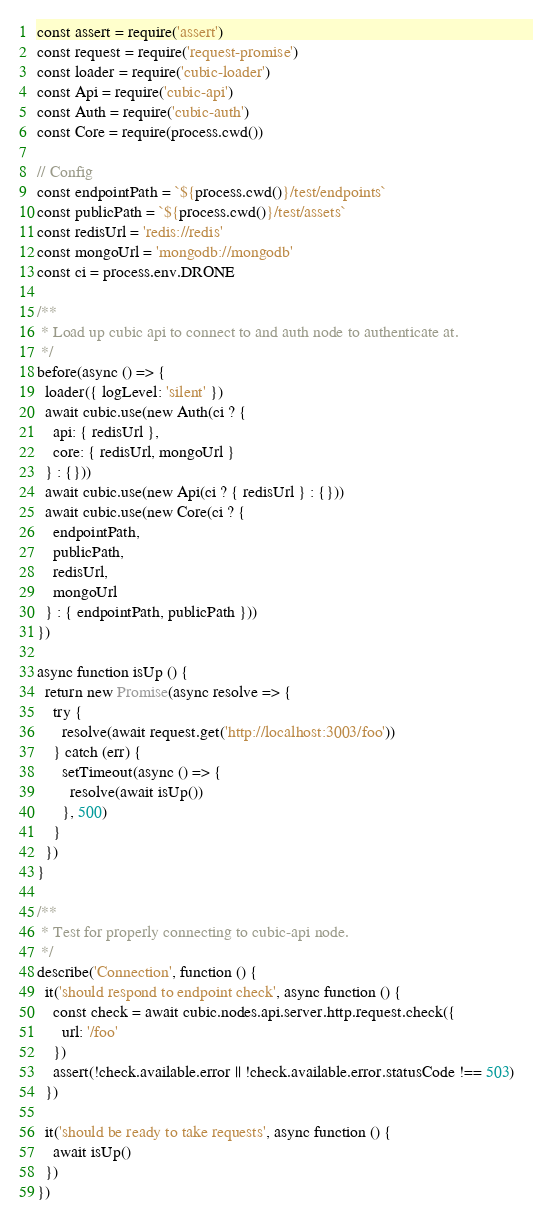Convert code to text. <code><loc_0><loc_0><loc_500><loc_500><_JavaScript_>const assert = require('assert')
const request = require('request-promise')
const loader = require('cubic-loader')
const Api = require('cubic-api')
const Auth = require('cubic-auth')
const Core = require(process.cwd())

// Config
const endpointPath = `${process.cwd()}/test/endpoints`
const publicPath = `${process.cwd()}/test/assets`
const redisUrl = 'redis://redis'
const mongoUrl = 'mongodb://mongodb'
const ci = process.env.DRONE

/**
 * Load up cubic api to connect to and auth node to authenticate at.
 */
before(async () => {
  loader({ logLevel: 'silent' })
  await cubic.use(new Auth(ci ? {
    api: { redisUrl },
    core: { redisUrl, mongoUrl }
  } : {}))
  await cubic.use(new Api(ci ? { redisUrl } : {}))
  await cubic.use(new Core(ci ? {
    endpointPath,
    publicPath,
    redisUrl,
    mongoUrl
  } : { endpointPath, publicPath }))
})

async function isUp () {
  return new Promise(async resolve => {
    try {
      resolve(await request.get('http://localhost:3003/foo'))
    } catch (err) {
      setTimeout(async () => {
        resolve(await isUp())
      }, 500)
    }
  })
}

/**
 * Test for properly connecting to cubic-api node.
 */
describe('Connection', function () {
  it('should respond to endpoint check', async function () {
    const check = await cubic.nodes.api.server.http.request.check({
      url: '/foo'
    })
    assert(!check.available.error || !check.available.error.statusCode !== 503)
  })

  it('should be ready to take requests', async function () {
    await isUp()
  })
})
</code> 